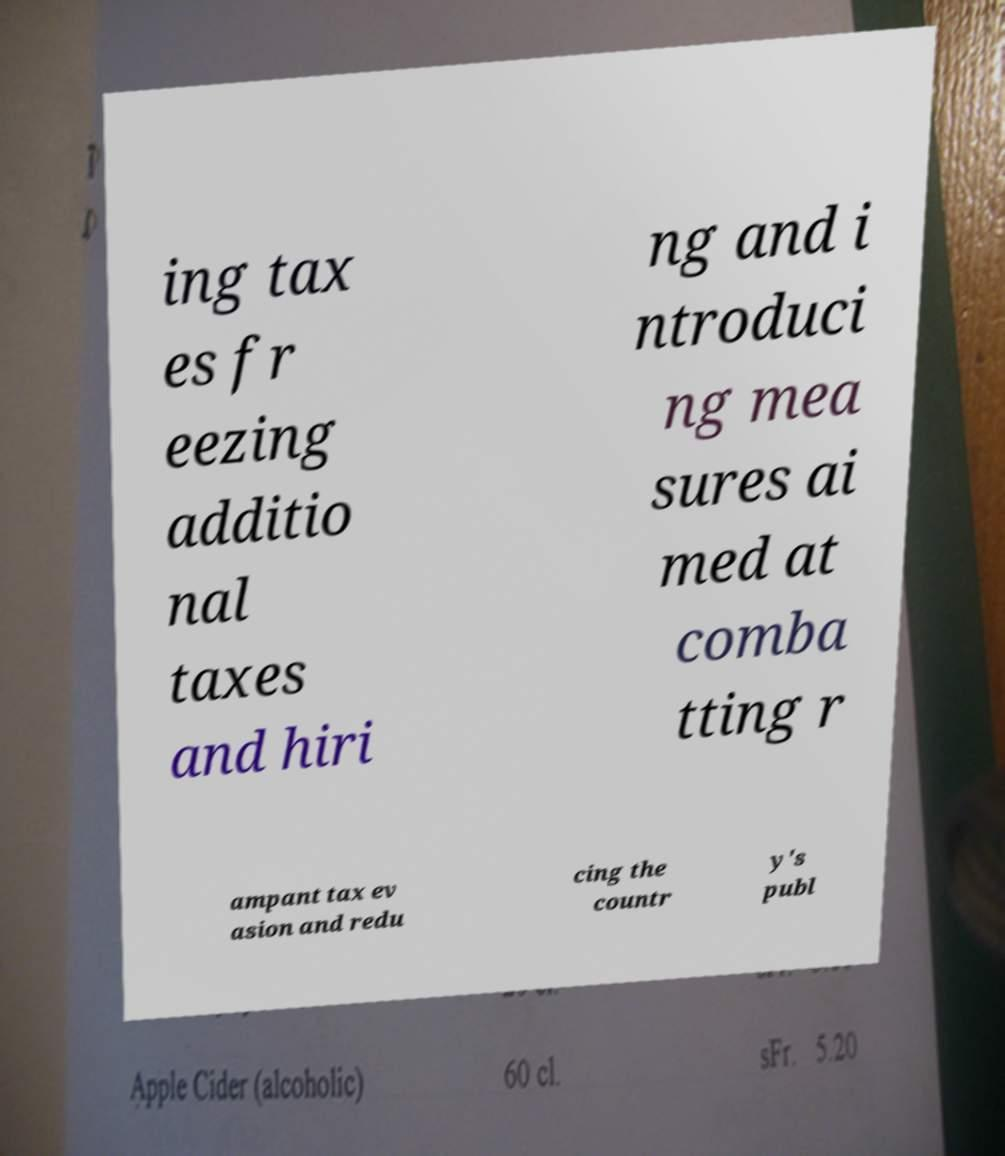There's text embedded in this image that I need extracted. Can you transcribe it verbatim? ing tax es fr eezing additio nal taxes and hiri ng and i ntroduci ng mea sures ai med at comba tting r ampant tax ev asion and redu cing the countr y's publ 